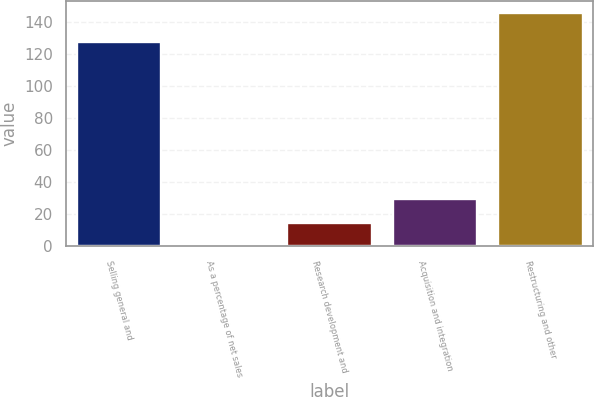Convert chart to OTSL. <chart><loc_0><loc_0><loc_500><loc_500><bar_chart><fcel>Selling general and<fcel>As a percentage of net sales<fcel>Research development and<fcel>Acquisition and integration<fcel>Restructuring and other<nl><fcel>128<fcel>0.1<fcel>14.69<fcel>29.28<fcel>146<nl></chart> 